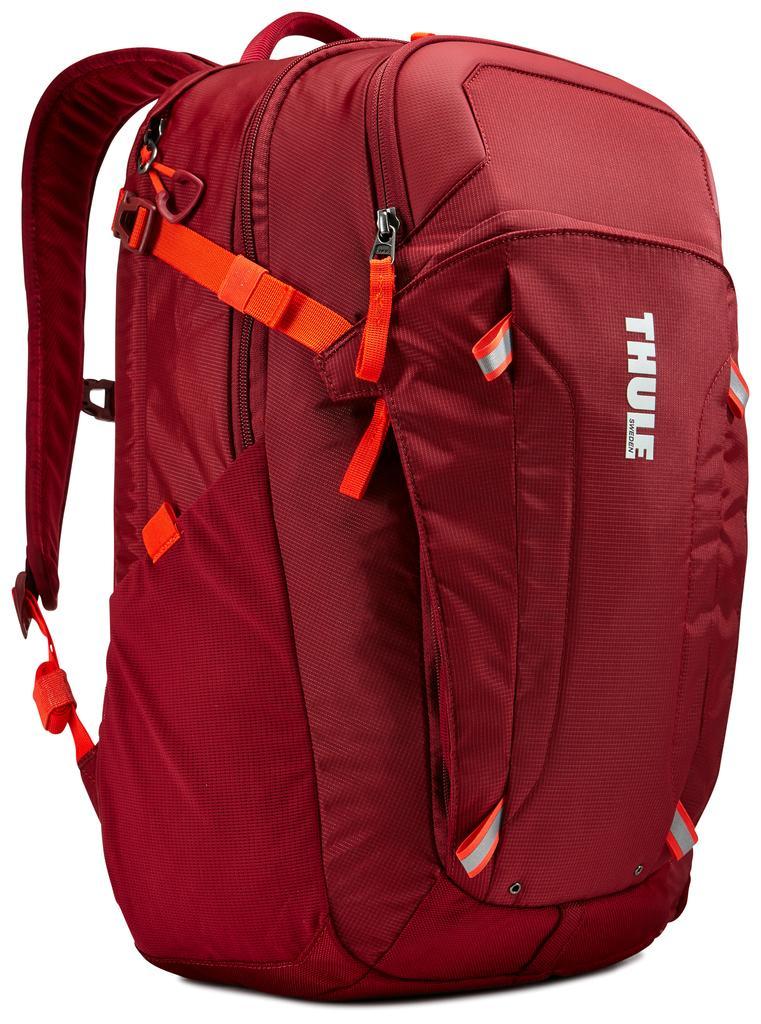In one or two sentences, can you explain what this image depicts? In this image there is a red backpack with orange stripe, it has three zips. 